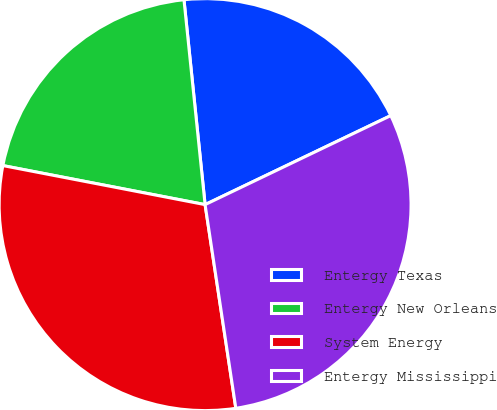Convert chart. <chart><loc_0><loc_0><loc_500><loc_500><pie_chart><fcel>Entergy Texas<fcel>Entergy New Orleans<fcel>System Energy<fcel>Entergy Mississippi<nl><fcel>19.52%<fcel>20.33%<fcel>30.42%<fcel>29.73%<nl></chart> 